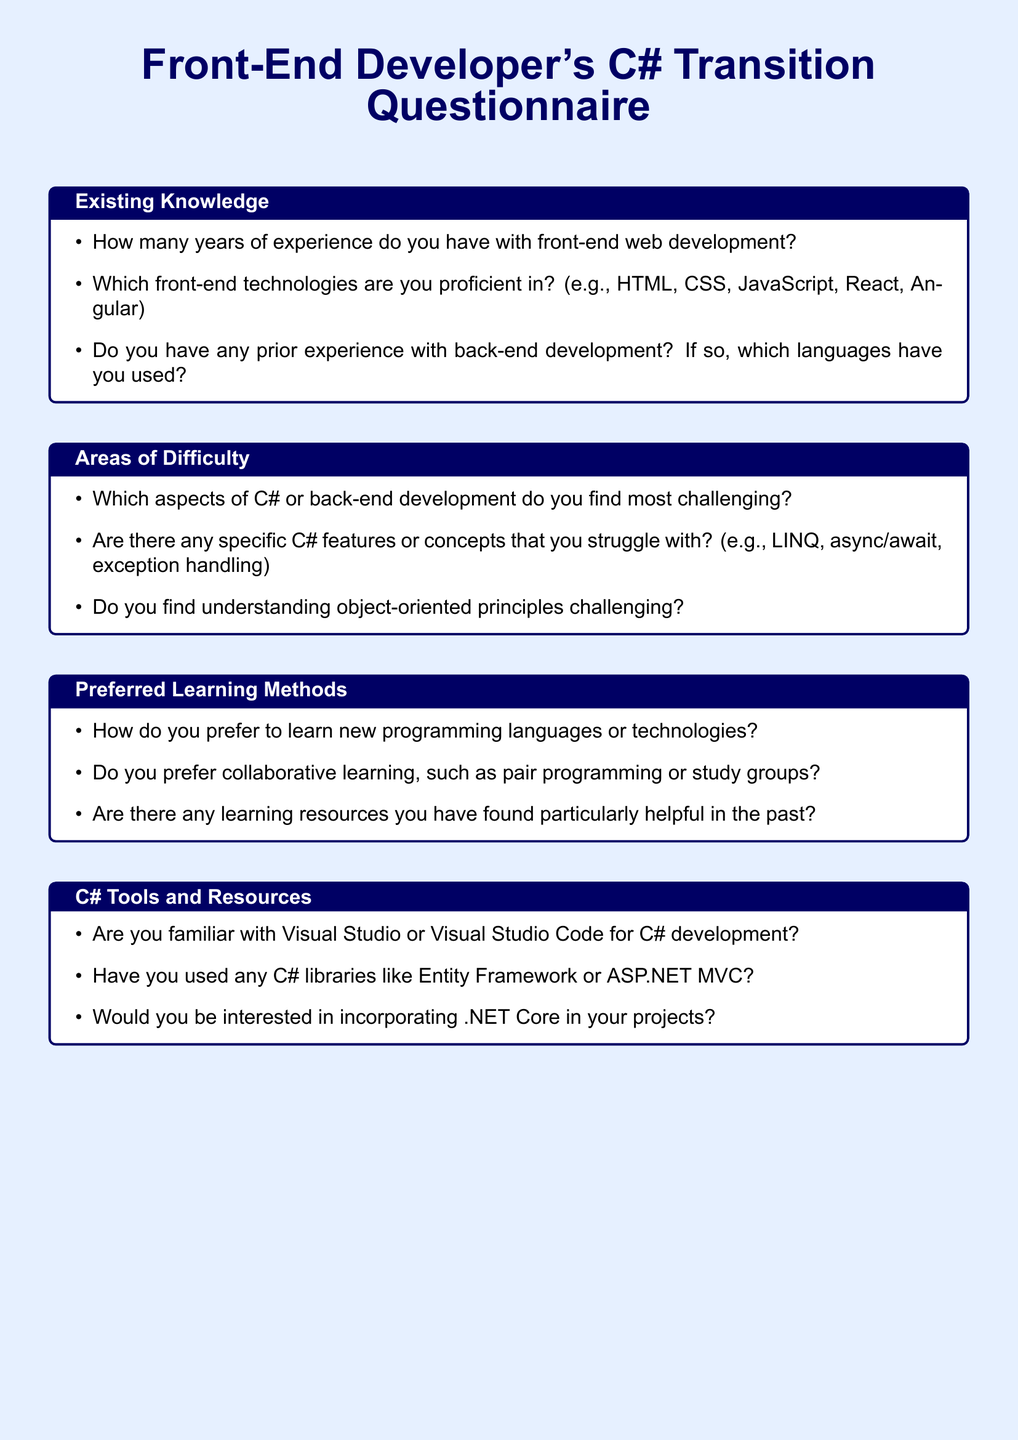How many years of experience do you have with front-end web development? The document asks for the number of years of experience a respondent has with front-end development.
Answer: years of experience Which front-end technologies are mentioned in the questionnaire? The document lists specific front-end technologies that the respondent can indicate proficiency in, including HTML, CSS, JavaScript, React, Angular.
Answer: HTML, CSS, JavaScript, React, Angular What specific C# features does the questionnaire ask about related to difficulty? The document mentions particular C# features or concepts that respondents might struggle with, such as LINQ, async/await, and exception handling.
Answer: LINQ, async/await, exception handling What is the title of the section that discusses tools and resources? The document specifies the title of the section covering tools and resources related to C# development.
Answer: C# Tools and Resources Are respondents encouraged to use collaborative learning methods? The questionnaire asks about preferences for collaborative learning, indicating that this is an area discussed in the document.
Answer: Yes What programming environment is mentioned for C# development in the questionnaire? The document references specific integrated development environments for C# development.
Answer: Visual Studio or Visual Studio Code Which areas are assessed under "Existing Knowledge" in the questionnaire? The document outlines various aspects under the section "Existing Knowledge," focusing on experience and technology proficiency.
Answer: experience, technologies Does the document mention any specific C# libraries that respondents should be aware of? The questionnaire includes questions about familiarity with certain C# libraries, indicating specific examples.
Answer: Entity Framework or ASP.NET MVC What learning resources have been found helpful according to the questionnaire? The document asks respondents to specify any learning resources that they have previously found beneficial.
Answer: specific learning resources 